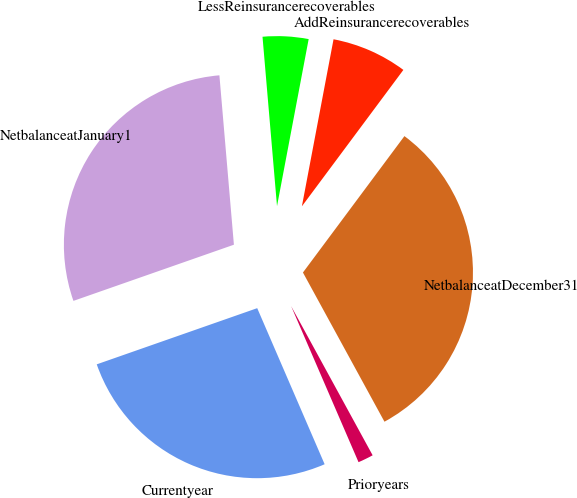Convert chart. <chart><loc_0><loc_0><loc_500><loc_500><pie_chart><fcel>LessReinsurancerecoverables<fcel>NetbalanceatJanuary1<fcel>Currentyear<fcel>Prioryears<fcel>NetbalanceatDecember31<fcel>AddReinsurancerecoverables<nl><fcel>4.34%<fcel>29.0%<fcel>26.13%<fcel>1.47%<fcel>31.86%<fcel>7.2%<nl></chart> 